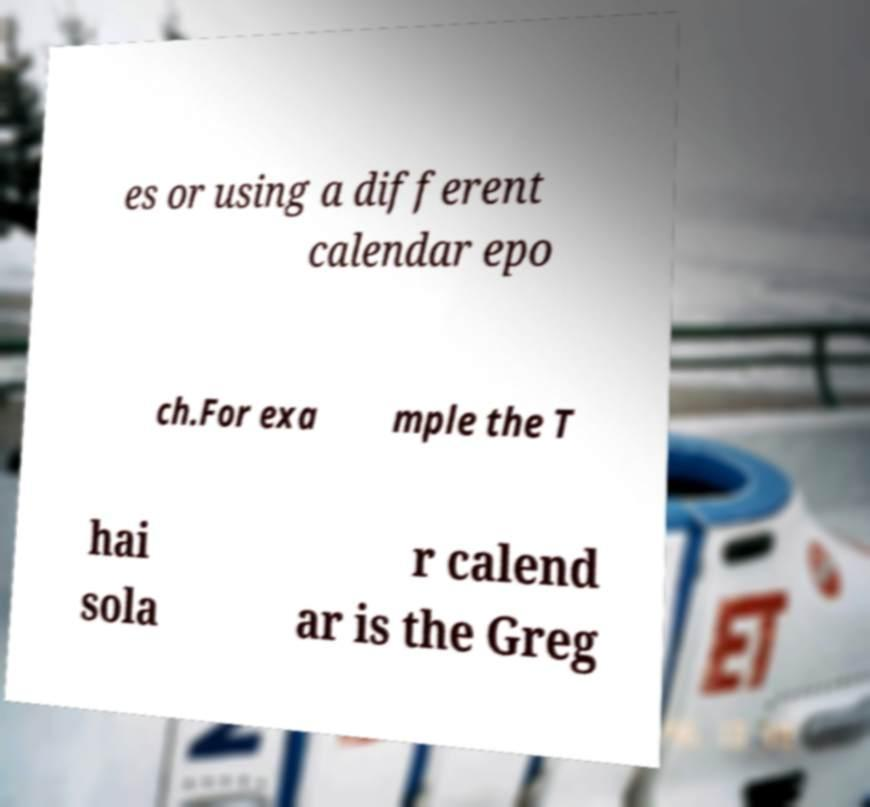For documentation purposes, I need the text within this image transcribed. Could you provide that? es or using a different calendar epo ch.For exa mple the T hai sola r calend ar is the Greg 